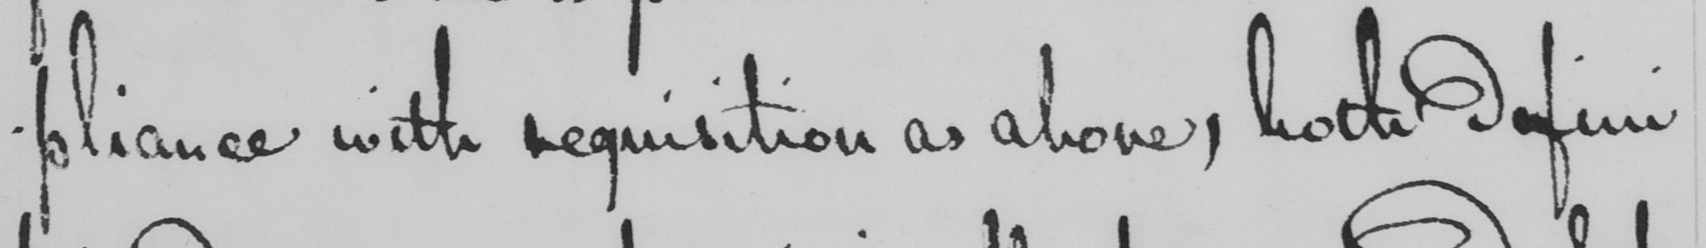What is written in this line of handwriting? -pliance with requisition as above , both defini- 